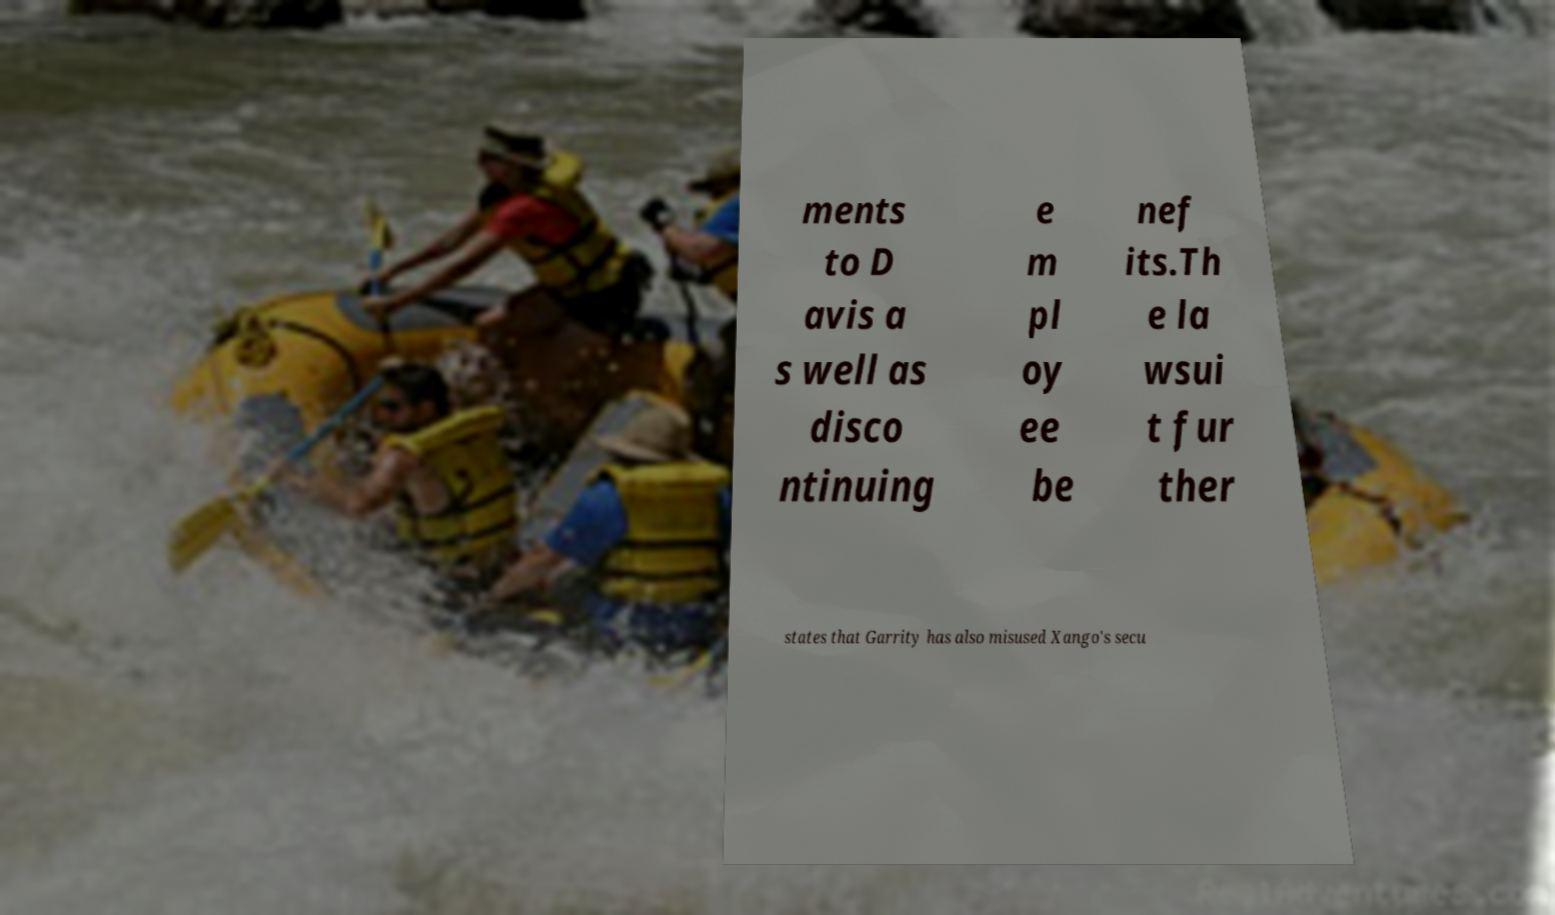Please read and relay the text visible in this image. What does it say? ments to D avis a s well as disco ntinuing e m pl oy ee be nef its.Th e la wsui t fur ther states that Garrity has also misused Xango's secu 